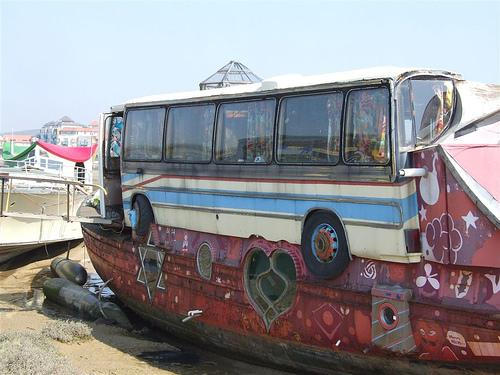What do people most likely do in the structure?

Choices:
A) sleep
B) vote
C) run
D) swim sleep 